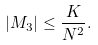Convert formula to latex. <formula><loc_0><loc_0><loc_500><loc_500>\left | M _ { 3 } \right | \leq \frac { K } { N ^ { 2 } } .</formula> 